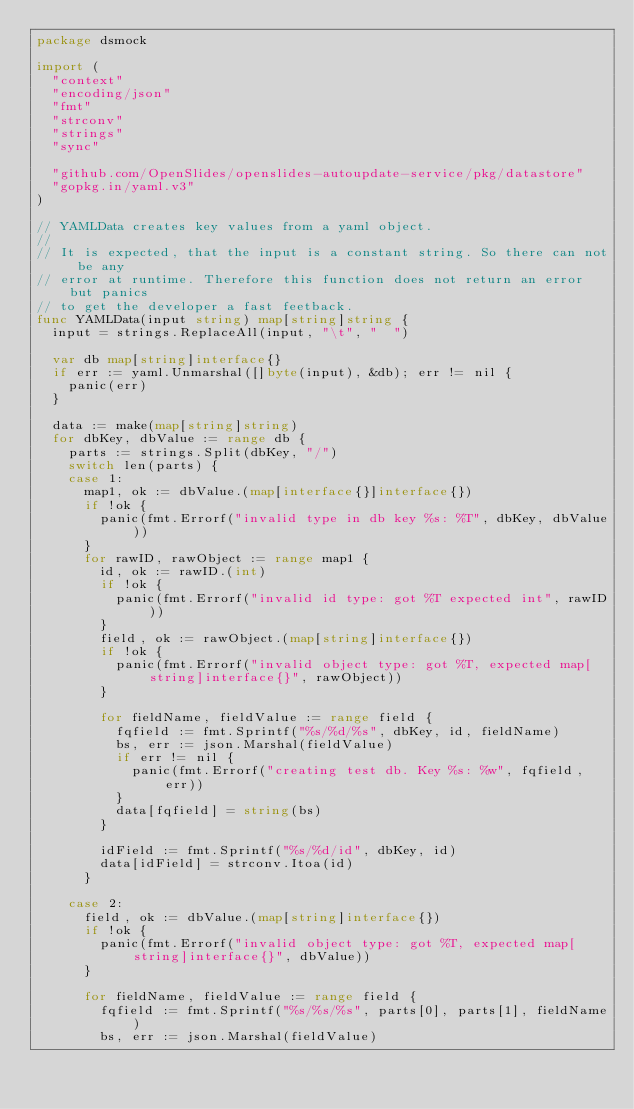<code> <loc_0><loc_0><loc_500><loc_500><_Go_>package dsmock

import (
	"context"
	"encoding/json"
	"fmt"
	"strconv"
	"strings"
	"sync"

	"github.com/OpenSlides/openslides-autoupdate-service/pkg/datastore"
	"gopkg.in/yaml.v3"
)

// YAMLData creates key values from a yaml object.
//
// It is expected, that the input is a constant string. So there can not be any
// error at runtime. Therefore this function does not return an error but panics
// to get the developer a fast feetback.
func YAMLData(input string) map[string]string {
	input = strings.ReplaceAll(input, "\t", "  ")

	var db map[string]interface{}
	if err := yaml.Unmarshal([]byte(input), &db); err != nil {
		panic(err)
	}

	data := make(map[string]string)
	for dbKey, dbValue := range db {
		parts := strings.Split(dbKey, "/")
		switch len(parts) {
		case 1:
			map1, ok := dbValue.(map[interface{}]interface{})
			if !ok {
				panic(fmt.Errorf("invalid type in db key %s: %T", dbKey, dbValue))
			}
			for rawID, rawObject := range map1 {
				id, ok := rawID.(int)
				if !ok {
					panic(fmt.Errorf("invalid id type: got %T expected int", rawID))
				}
				field, ok := rawObject.(map[string]interface{})
				if !ok {
					panic(fmt.Errorf("invalid object type: got %T, expected map[string]interface{}", rawObject))
				}

				for fieldName, fieldValue := range field {
					fqfield := fmt.Sprintf("%s/%d/%s", dbKey, id, fieldName)
					bs, err := json.Marshal(fieldValue)
					if err != nil {
						panic(fmt.Errorf("creating test db. Key %s: %w", fqfield, err))
					}
					data[fqfield] = string(bs)
				}

				idField := fmt.Sprintf("%s/%d/id", dbKey, id)
				data[idField] = strconv.Itoa(id)
			}

		case 2:
			field, ok := dbValue.(map[string]interface{})
			if !ok {
				panic(fmt.Errorf("invalid object type: got %T, expected map[string]interface{}", dbValue))
			}

			for fieldName, fieldValue := range field {
				fqfield := fmt.Sprintf("%s/%s/%s", parts[0], parts[1], fieldName)
				bs, err := json.Marshal(fieldValue)</code> 